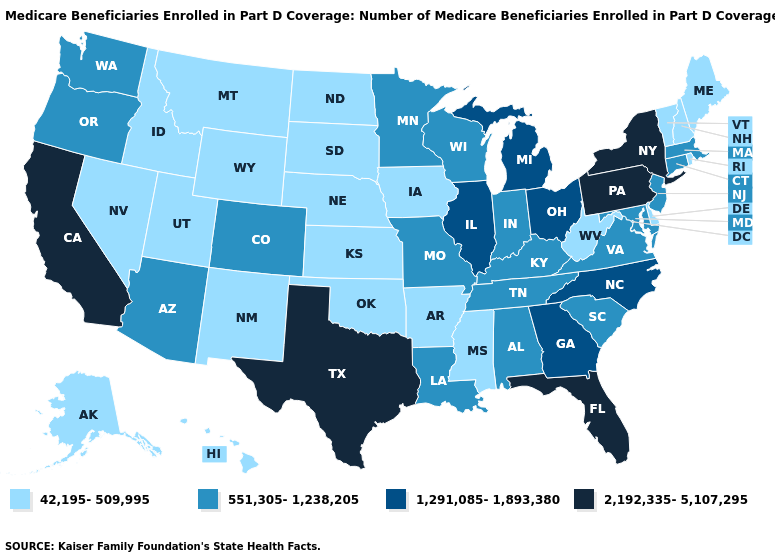Name the states that have a value in the range 42,195-509,995?
Answer briefly. Alaska, Arkansas, Delaware, Hawaii, Idaho, Iowa, Kansas, Maine, Mississippi, Montana, Nebraska, Nevada, New Hampshire, New Mexico, North Dakota, Oklahoma, Rhode Island, South Dakota, Utah, Vermont, West Virginia, Wyoming. What is the highest value in the South ?
Concise answer only. 2,192,335-5,107,295. Name the states that have a value in the range 2,192,335-5,107,295?
Write a very short answer. California, Florida, New York, Pennsylvania, Texas. Is the legend a continuous bar?
Concise answer only. No. Does the map have missing data?
Keep it brief. No. What is the value of New Jersey?
Quick response, please. 551,305-1,238,205. What is the lowest value in the USA?
Answer briefly. 42,195-509,995. What is the value of Texas?
Keep it brief. 2,192,335-5,107,295. Name the states that have a value in the range 551,305-1,238,205?
Concise answer only. Alabama, Arizona, Colorado, Connecticut, Indiana, Kentucky, Louisiana, Maryland, Massachusetts, Minnesota, Missouri, New Jersey, Oregon, South Carolina, Tennessee, Virginia, Washington, Wisconsin. Is the legend a continuous bar?
Answer briefly. No. Name the states that have a value in the range 42,195-509,995?
Concise answer only. Alaska, Arkansas, Delaware, Hawaii, Idaho, Iowa, Kansas, Maine, Mississippi, Montana, Nebraska, Nevada, New Hampshire, New Mexico, North Dakota, Oklahoma, Rhode Island, South Dakota, Utah, Vermont, West Virginia, Wyoming. What is the highest value in the South ?
Concise answer only. 2,192,335-5,107,295. What is the value of Wisconsin?
Concise answer only. 551,305-1,238,205. Among the states that border Utah , does Colorado have the highest value?
Concise answer only. Yes. Among the states that border South Carolina , which have the lowest value?
Answer briefly. Georgia, North Carolina. 